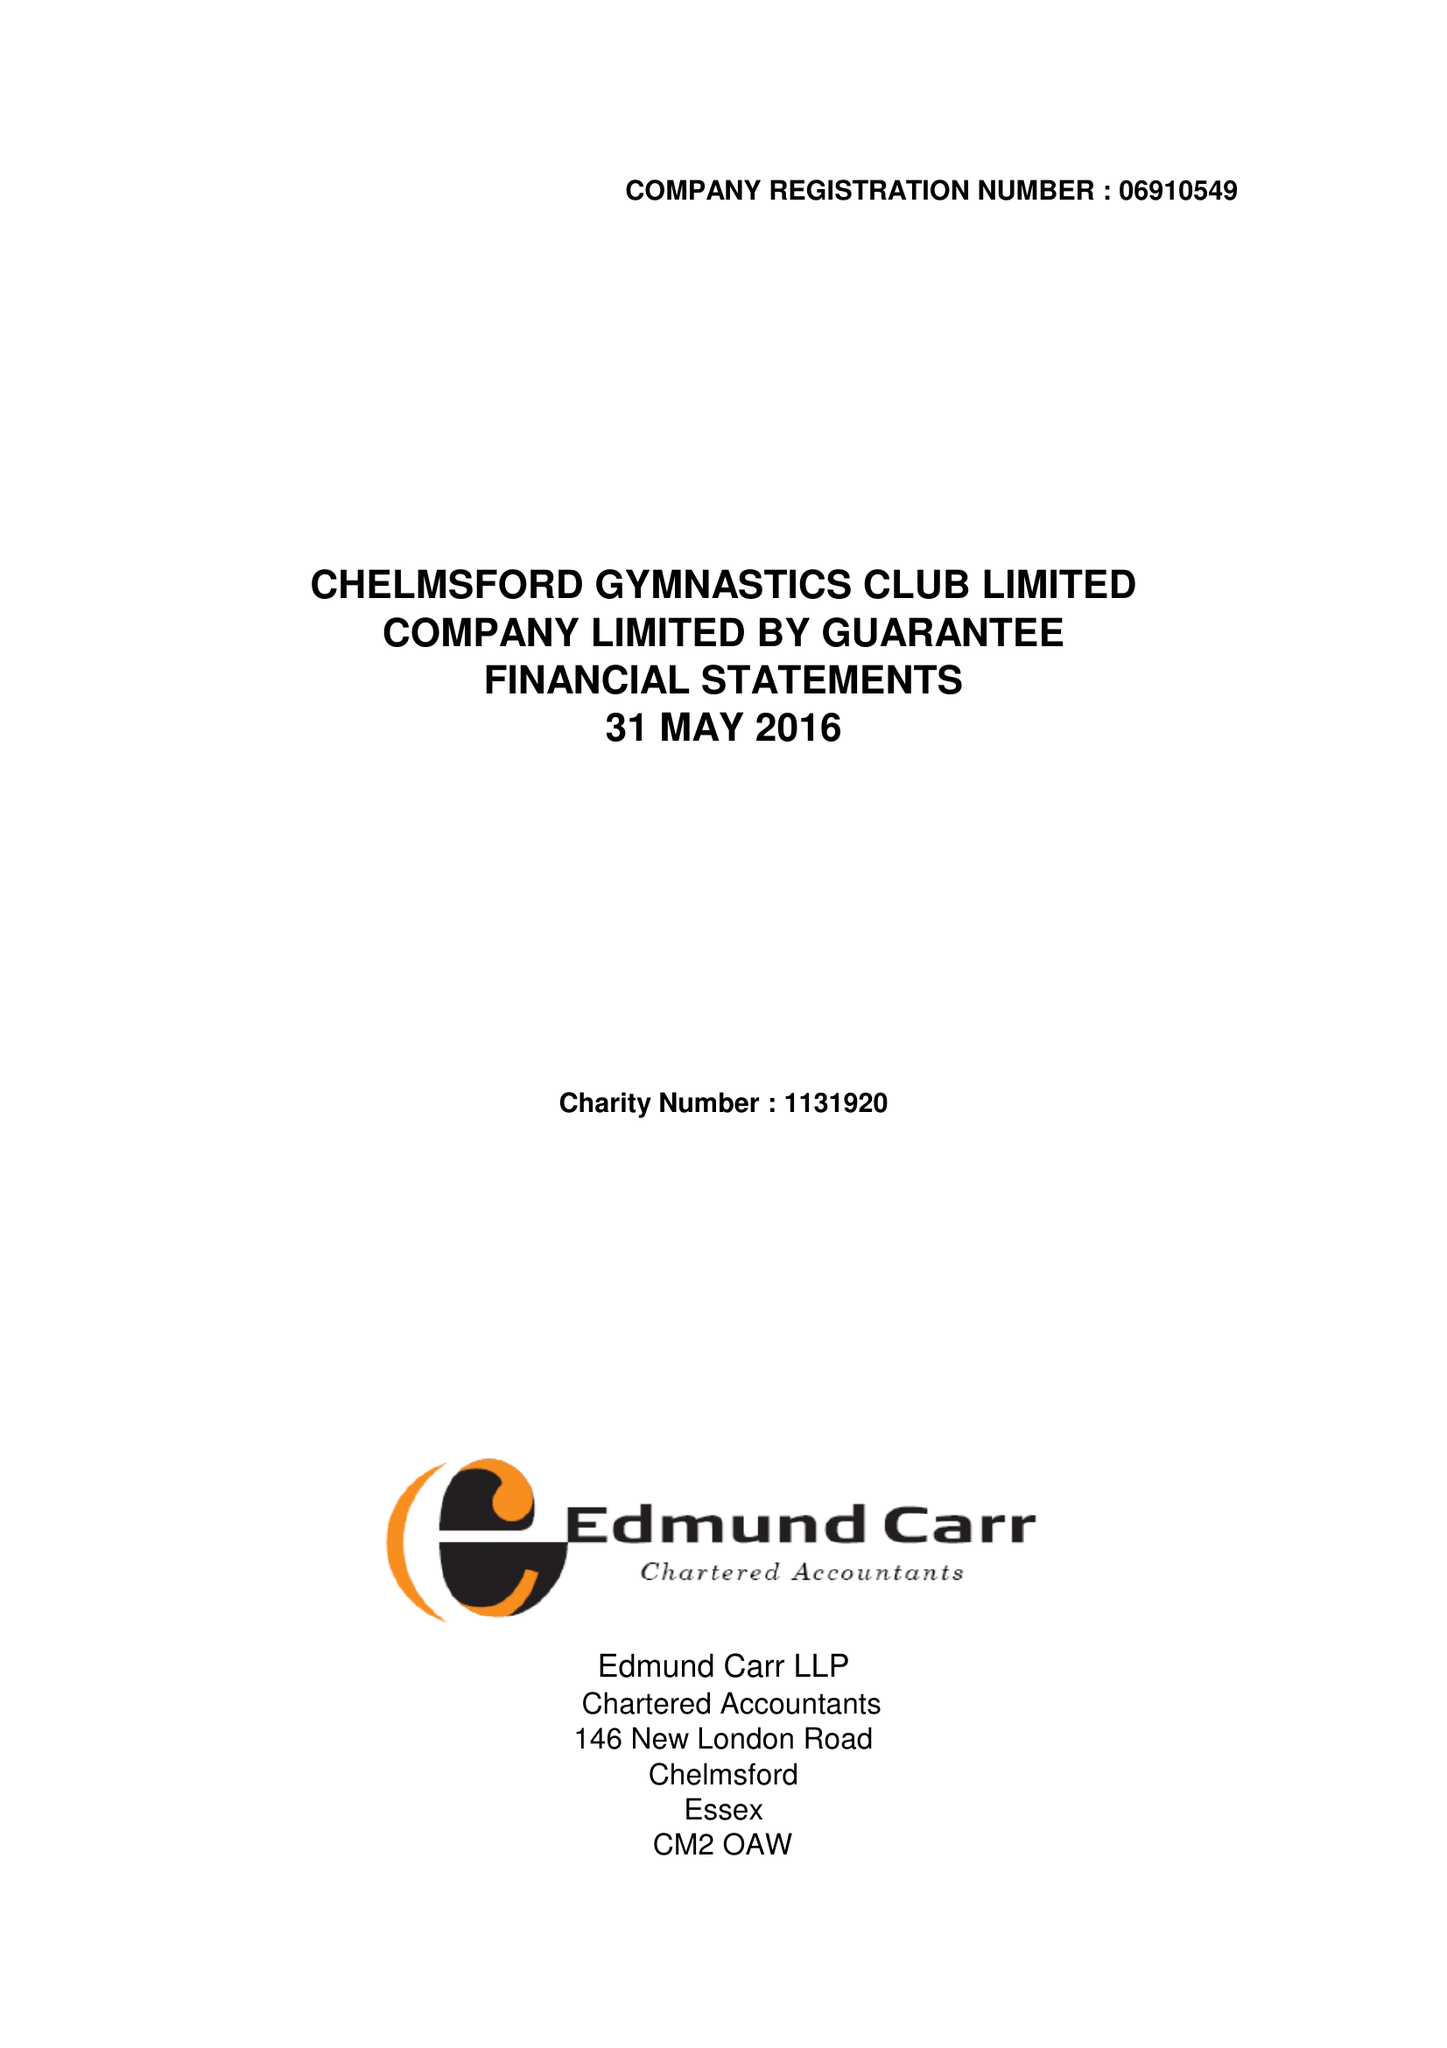What is the value for the address__postcode?
Answer the question using a single word or phrase. CM2 6BX 